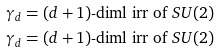<formula> <loc_0><loc_0><loc_500><loc_500>\gamma _ { d } & = \text {$(d+1)$-diml irr of $SU(2)$} \\ \gamma _ { d } & = \text {$(d+1)$-diml irr of $SU(2)$}</formula> 